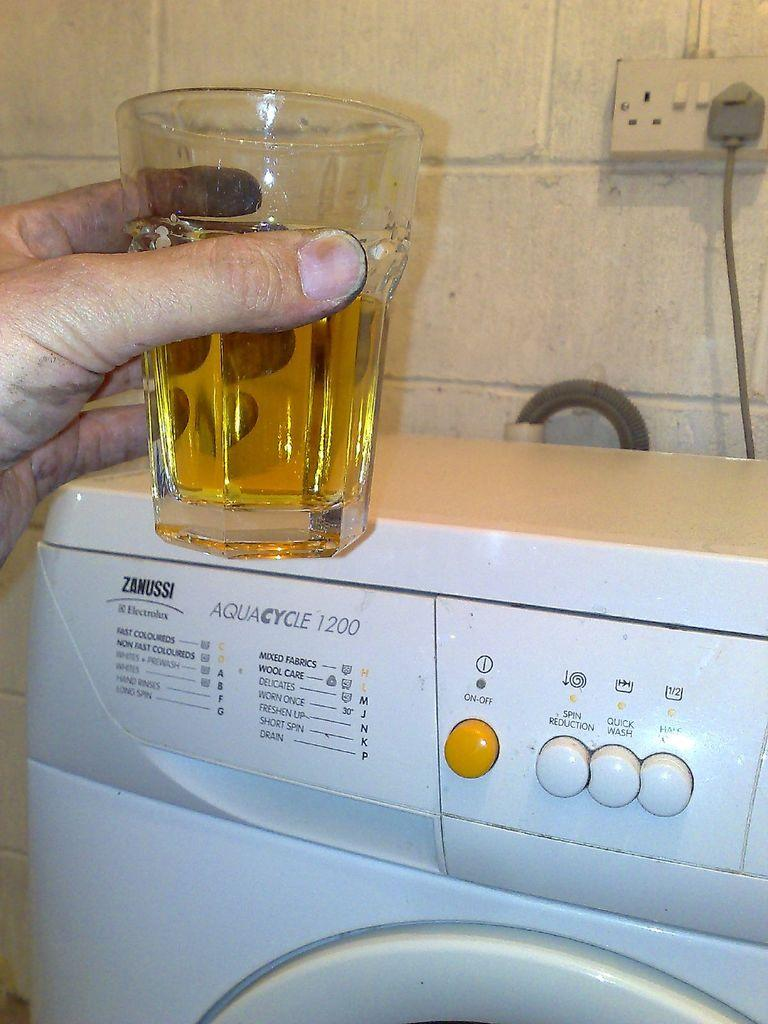<image>
Describe the image concisely. A man holds up a drink in front of a Zanussi washing machine. 